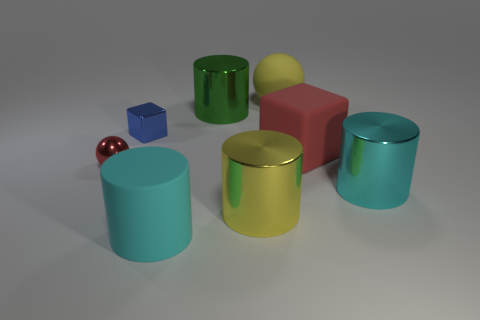Is the number of tiny blue metal cubes greater than the number of small metallic objects? After careful examination, it appears that while there is only one small blue metal cube present, there are several other small metallic objects, including cylinders and spheres, indicating that the number of tiny blue metal cubes is not greater than the number of small metallic objects in total. 